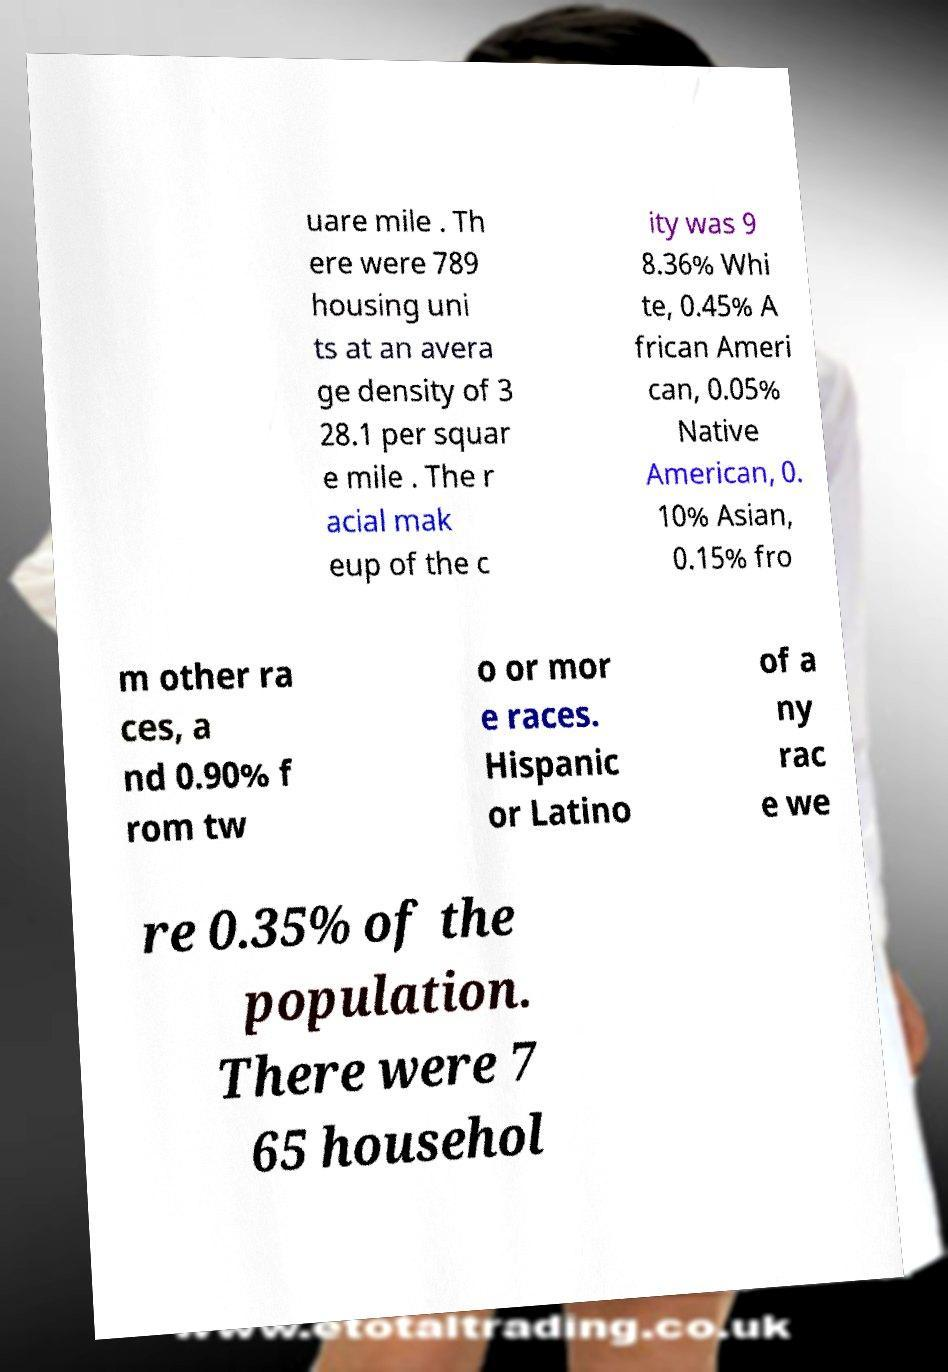For documentation purposes, I need the text within this image transcribed. Could you provide that? uare mile . Th ere were 789 housing uni ts at an avera ge density of 3 28.1 per squar e mile . The r acial mak eup of the c ity was 9 8.36% Whi te, 0.45% A frican Ameri can, 0.05% Native American, 0. 10% Asian, 0.15% fro m other ra ces, a nd 0.90% f rom tw o or mor e races. Hispanic or Latino of a ny rac e we re 0.35% of the population. There were 7 65 househol 